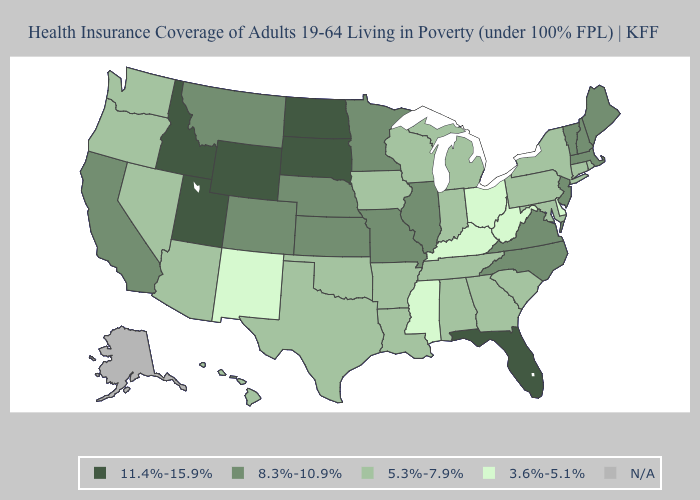What is the value of Colorado?
Concise answer only. 8.3%-10.9%. Does Georgia have the lowest value in the USA?
Give a very brief answer. No. What is the value of Texas?
Keep it brief. 5.3%-7.9%. Which states have the lowest value in the USA?
Give a very brief answer. Delaware, Kentucky, Mississippi, New Mexico, Ohio, West Virginia. What is the highest value in the USA?
Be succinct. 11.4%-15.9%. What is the value of Indiana?
Write a very short answer. 5.3%-7.9%. What is the value of Ohio?
Quick response, please. 3.6%-5.1%. What is the value of Maine?
Short answer required. 8.3%-10.9%. Name the states that have a value in the range 3.6%-5.1%?
Be succinct. Delaware, Kentucky, Mississippi, New Mexico, Ohio, West Virginia. Does the map have missing data?
Concise answer only. Yes. What is the value of New Hampshire?
Write a very short answer. 8.3%-10.9%. What is the value of New Jersey?
Quick response, please. 8.3%-10.9%. Name the states that have a value in the range 8.3%-10.9%?
Short answer required. California, Colorado, Illinois, Kansas, Maine, Massachusetts, Minnesota, Missouri, Montana, Nebraska, New Hampshire, New Jersey, North Carolina, Vermont, Virginia. What is the value of South Dakota?
Write a very short answer. 11.4%-15.9%. Which states have the lowest value in the USA?
Short answer required. Delaware, Kentucky, Mississippi, New Mexico, Ohio, West Virginia. 